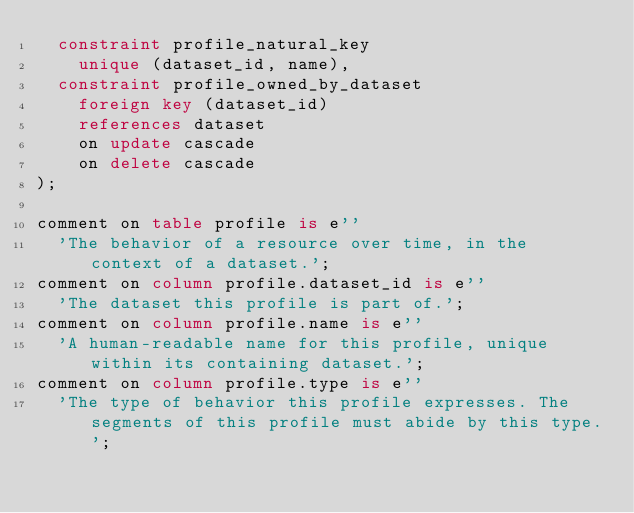Convert code to text. <code><loc_0><loc_0><loc_500><loc_500><_SQL_>  constraint profile_natural_key
    unique (dataset_id, name),
  constraint profile_owned_by_dataset
    foreign key (dataset_id)
    references dataset
    on update cascade
    on delete cascade
);

comment on table profile is e''
  'The behavior of a resource over time, in the context of a dataset.';
comment on column profile.dataset_id is e''
  'The dataset this profile is part of.';
comment on column profile.name is e''
  'A human-readable name for this profile, unique within its containing dataset.';
comment on column profile.type is e''
  'The type of behavior this profile expresses. The segments of this profile must abide by this type.';
</code> 